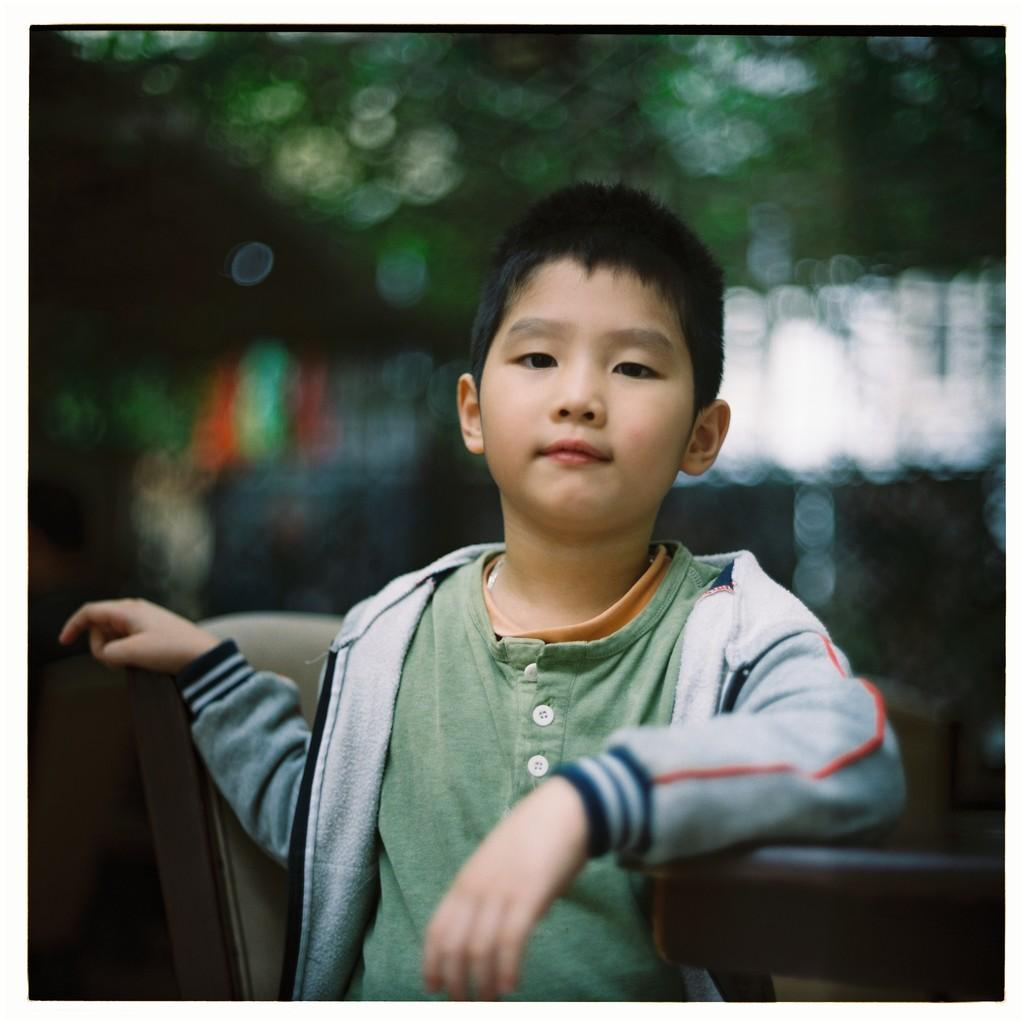What is the main subject of the image? The main subject of the image is a child. What is the child wearing in the image? The child is wearing a gray color jacket. What is the child's facial expression in the image? The child is smiling in the image. What is the child doing with their hand in the image? The child is placing a hand on a wooden object. How would you describe the background of the image? The background of the image is blurred. What type of memory is stored in the child's pocket in the image? There is no mention of a pocket or memory in the image; the child is wearing a jacket and placing a hand on a wooden object. 